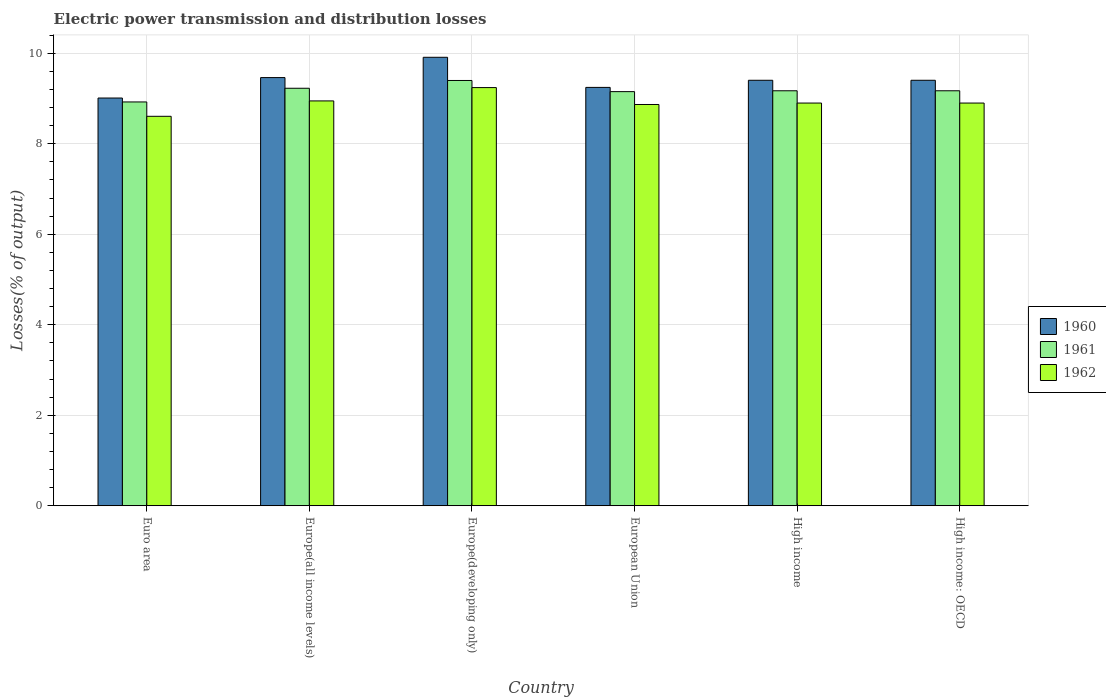How many groups of bars are there?
Your answer should be very brief. 6. Are the number of bars on each tick of the X-axis equal?
Your response must be concise. Yes. How many bars are there on the 2nd tick from the right?
Give a very brief answer. 3. What is the label of the 5th group of bars from the left?
Give a very brief answer. High income. In how many cases, is the number of bars for a given country not equal to the number of legend labels?
Provide a short and direct response. 0. What is the electric power transmission and distribution losses in 1960 in Europe(developing only)?
Your answer should be compact. 9.91. Across all countries, what is the maximum electric power transmission and distribution losses in 1962?
Offer a very short reply. 9.24. Across all countries, what is the minimum electric power transmission and distribution losses in 1961?
Your response must be concise. 8.92. In which country was the electric power transmission and distribution losses in 1962 maximum?
Your answer should be compact. Europe(developing only). What is the total electric power transmission and distribution losses in 1962 in the graph?
Your answer should be very brief. 53.46. What is the difference between the electric power transmission and distribution losses in 1962 in Europe(developing only) and that in European Union?
Ensure brevity in your answer.  0.37. What is the difference between the electric power transmission and distribution losses in 1962 in High income: OECD and the electric power transmission and distribution losses in 1960 in European Union?
Offer a very short reply. -0.35. What is the average electric power transmission and distribution losses in 1962 per country?
Your answer should be very brief. 8.91. What is the difference between the electric power transmission and distribution losses of/in 1960 and electric power transmission and distribution losses of/in 1961 in High income?
Make the answer very short. 0.23. In how many countries, is the electric power transmission and distribution losses in 1961 greater than 6 %?
Provide a succinct answer. 6. What is the ratio of the electric power transmission and distribution losses in 1960 in Europe(all income levels) to that in High income?
Offer a terse response. 1.01. Is the electric power transmission and distribution losses in 1962 in Euro area less than that in Europe(all income levels)?
Your answer should be very brief. Yes. What is the difference between the highest and the second highest electric power transmission and distribution losses in 1961?
Make the answer very short. 0.17. What is the difference between the highest and the lowest electric power transmission and distribution losses in 1960?
Offer a terse response. 0.9. Is the sum of the electric power transmission and distribution losses in 1962 in Europe(developing only) and High income: OECD greater than the maximum electric power transmission and distribution losses in 1960 across all countries?
Offer a very short reply. Yes. What does the 1st bar from the left in Europe(developing only) represents?
Your answer should be compact. 1960. Is it the case that in every country, the sum of the electric power transmission and distribution losses in 1960 and electric power transmission and distribution losses in 1961 is greater than the electric power transmission and distribution losses in 1962?
Keep it short and to the point. Yes. How many bars are there?
Keep it short and to the point. 18. Are all the bars in the graph horizontal?
Offer a very short reply. No. How many countries are there in the graph?
Your answer should be very brief. 6. What is the difference between two consecutive major ticks on the Y-axis?
Give a very brief answer. 2. Does the graph contain any zero values?
Offer a very short reply. No. Does the graph contain grids?
Give a very brief answer. Yes. How many legend labels are there?
Ensure brevity in your answer.  3. How are the legend labels stacked?
Provide a succinct answer. Vertical. What is the title of the graph?
Your answer should be compact. Electric power transmission and distribution losses. Does "1976" appear as one of the legend labels in the graph?
Offer a terse response. No. What is the label or title of the Y-axis?
Provide a short and direct response. Losses(% of output). What is the Losses(% of output) in 1960 in Euro area?
Offer a very short reply. 9.01. What is the Losses(% of output) of 1961 in Euro area?
Keep it short and to the point. 8.92. What is the Losses(% of output) in 1962 in Euro area?
Keep it short and to the point. 8.61. What is the Losses(% of output) of 1960 in Europe(all income levels)?
Ensure brevity in your answer.  9.46. What is the Losses(% of output) in 1961 in Europe(all income levels)?
Provide a short and direct response. 9.23. What is the Losses(% of output) of 1962 in Europe(all income levels)?
Give a very brief answer. 8.95. What is the Losses(% of output) in 1960 in Europe(developing only)?
Ensure brevity in your answer.  9.91. What is the Losses(% of output) of 1961 in Europe(developing only)?
Offer a terse response. 9.4. What is the Losses(% of output) of 1962 in Europe(developing only)?
Provide a succinct answer. 9.24. What is the Losses(% of output) of 1960 in European Union?
Your answer should be compact. 9.25. What is the Losses(% of output) of 1961 in European Union?
Give a very brief answer. 9.15. What is the Losses(% of output) of 1962 in European Union?
Keep it short and to the point. 8.87. What is the Losses(% of output) of 1960 in High income?
Your response must be concise. 9.4. What is the Losses(% of output) in 1961 in High income?
Offer a terse response. 9.17. What is the Losses(% of output) of 1962 in High income?
Provide a succinct answer. 8.9. What is the Losses(% of output) in 1960 in High income: OECD?
Ensure brevity in your answer.  9.4. What is the Losses(% of output) in 1961 in High income: OECD?
Provide a short and direct response. 9.17. What is the Losses(% of output) of 1962 in High income: OECD?
Your answer should be compact. 8.9. Across all countries, what is the maximum Losses(% of output) of 1960?
Make the answer very short. 9.91. Across all countries, what is the maximum Losses(% of output) in 1961?
Offer a very short reply. 9.4. Across all countries, what is the maximum Losses(% of output) of 1962?
Your response must be concise. 9.24. Across all countries, what is the minimum Losses(% of output) of 1960?
Provide a succinct answer. 9.01. Across all countries, what is the minimum Losses(% of output) of 1961?
Ensure brevity in your answer.  8.92. Across all countries, what is the minimum Losses(% of output) of 1962?
Give a very brief answer. 8.61. What is the total Losses(% of output) in 1960 in the graph?
Your response must be concise. 56.44. What is the total Losses(% of output) of 1961 in the graph?
Keep it short and to the point. 55.04. What is the total Losses(% of output) of 1962 in the graph?
Your response must be concise. 53.46. What is the difference between the Losses(% of output) in 1960 in Euro area and that in Europe(all income levels)?
Offer a very short reply. -0.45. What is the difference between the Losses(% of output) of 1961 in Euro area and that in Europe(all income levels)?
Make the answer very short. -0.3. What is the difference between the Losses(% of output) in 1962 in Euro area and that in Europe(all income levels)?
Provide a short and direct response. -0.34. What is the difference between the Losses(% of output) in 1961 in Euro area and that in Europe(developing only)?
Provide a short and direct response. -0.47. What is the difference between the Losses(% of output) of 1962 in Euro area and that in Europe(developing only)?
Your response must be concise. -0.63. What is the difference between the Losses(% of output) in 1960 in Euro area and that in European Union?
Provide a short and direct response. -0.23. What is the difference between the Losses(% of output) in 1961 in Euro area and that in European Union?
Your answer should be very brief. -0.23. What is the difference between the Losses(% of output) of 1962 in Euro area and that in European Union?
Your answer should be very brief. -0.26. What is the difference between the Losses(% of output) in 1960 in Euro area and that in High income?
Offer a terse response. -0.39. What is the difference between the Losses(% of output) of 1961 in Euro area and that in High income?
Your answer should be very brief. -0.25. What is the difference between the Losses(% of output) of 1962 in Euro area and that in High income?
Give a very brief answer. -0.29. What is the difference between the Losses(% of output) in 1960 in Euro area and that in High income: OECD?
Your answer should be compact. -0.39. What is the difference between the Losses(% of output) of 1961 in Euro area and that in High income: OECD?
Make the answer very short. -0.25. What is the difference between the Losses(% of output) in 1962 in Euro area and that in High income: OECD?
Make the answer very short. -0.29. What is the difference between the Losses(% of output) in 1960 in Europe(all income levels) and that in Europe(developing only)?
Provide a short and direct response. -0.45. What is the difference between the Losses(% of output) of 1961 in Europe(all income levels) and that in Europe(developing only)?
Your response must be concise. -0.17. What is the difference between the Losses(% of output) in 1962 in Europe(all income levels) and that in Europe(developing only)?
Your answer should be compact. -0.29. What is the difference between the Losses(% of output) in 1960 in Europe(all income levels) and that in European Union?
Your answer should be compact. 0.22. What is the difference between the Losses(% of output) in 1961 in Europe(all income levels) and that in European Union?
Provide a succinct answer. 0.07. What is the difference between the Losses(% of output) of 1962 in Europe(all income levels) and that in European Union?
Your answer should be very brief. 0.08. What is the difference between the Losses(% of output) in 1960 in Europe(all income levels) and that in High income?
Provide a short and direct response. 0.06. What is the difference between the Losses(% of output) in 1961 in Europe(all income levels) and that in High income?
Your answer should be compact. 0.06. What is the difference between the Losses(% of output) in 1962 in Europe(all income levels) and that in High income?
Make the answer very short. 0.05. What is the difference between the Losses(% of output) in 1960 in Europe(all income levels) and that in High income: OECD?
Your answer should be very brief. 0.06. What is the difference between the Losses(% of output) in 1961 in Europe(all income levels) and that in High income: OECD?
Keep it short and to the point. 0.06. What is the difference between the Losses(% of output) in 1962 in Europe(all income levels) and that in High income: OECD?
Ensure brevity in your answer.  0.05. What is the difference between the Losses(% of output) of 1960 in Europe(developing only) and that in European Union?
Offer a terse response. 0.67. What is the difference between the Losses(% of output) of 1961 in Europe(developing only) and that in European Union?
Provide a succinct answer. 0.25. What is the difference between the Losses(% of output) in 1962 in Europe(developing only) and that in European Union?
Give a very brief answer. 0.37. What is the difference between the Losses(% of output) in 1960 in Europe(developing only) and that in High income?
Make the answer very short. 0.51. What is the difference between the Losses(% of output) in 1961 in Europe(developing only) and that in High income?
Provide a short and direct response. 0.23. What is the difference between the Losses(% of output) in 1962 in Europe(developing only) and that in High income?
Offer a very short reply. 0.34. What is the difference between the Losses(% of output) in 1960 in Europe(developing only) and that in High income: OECD?
Provide a short and direct response. 0.51. What is the difference between the Losses(% of output) in 1961 in Europe(developing only) and that in High income: OECD?
Offer a very short reply. 0.23. What is the difference between the Losses(% of output) of 1962 in Europe(developing only) and that in High income: OECD?
Give a very brief answer. 0.34. What is the difference between the Losses(% of output) in 1960 in European Union and that in High income?
Offer a very short reply. -0.16. What is the difference between the Losses(% of output) in 1961 in European Union and that in High income?
Your answer should be very brief. -0.02. What is the difference between the Losses(% of output) in 1962 in European Union and that in High income?
Provide a succinct answer. -0.03. What is the difference between the Losses(% of output) in 1960 in European Union and that in High income: OECD?
Give a very brief answer. -0.16. What is the difference between the Losses(% of output) of 1961 in European Union and that in High income: OECD?
Offer a terse response. -0.02. What is the difference between the Losses(% of output) in 1962 in European Union and that in High income: OECD?
Provide a succinct answer. -0.03. What is the difference between the Losses(% of output) of 1960 in High income and that in High income: OECD?
Your answer should be very brief. 0. What is the difference between the Losses(% of output) in 1961 in High income and that in High income: OECD?
Provide a short and direct response. 0. What is the difference between the Losses(% of output) in 1962 in High income and that in High income: OECD?
Provide a short and direct response. 0. What is the difference between the Losses(% of output) in 1960 in Euro area and the Losses(% of output) in 1961 in Europe(all income levels)?
Keep it short and to the point. -0.22. What is the difference between the Losses(% of output) of 1960 in Euro area and the Losses(% of output) of 1962 in Europe(all income levels)?
Keep it short and to the point. 0.06. What is the difference between the Losses(% of output) of 1961 in Euro area and the Losses(% of output) of 1962 in Europe(all income levels)?
Your response must be concise. -0.02. What is the difference between the Losses(% of output) of 1960 in Euro area and the Losses(% of output) of 1961 in Europe(developing only)?
Make the answer very short. -0.39. What is the difference between the Losses(% of output) of 1960 in Euro area and the Losses(% of output) of 1962 in Europe(developing only)?
Your answer should be very brief. -0.23. What is the difference between the Losses(% of output) in 1961 in Euro area and the Losses(% of output) in 1962 in Europe(developing only)?
Ensure brevity in your answer.  -0.32. What is the difference between the Losses(% of output) in 1960 in Euro area and the Losses(% of output) in 1961 in European Union?
Your answer should be very brief. -0.14. What is the difference between the Losses(% of output) in 1960 in Euro area and the Losses(% of output) in 1962 in European Union?
Give a very brief answer. 0.14. What is the difference between the Losses(% of output) of 1961 in Euro area and the Losses(% of output) of 1962 in European Union?
Offer a terse response. 0.06. What is the difference between the Losses(% of output) in 1960 in Euro area and the Losses(% of output) in 1961 in High income?
Provide a short and direct response. -0.16. What is the difference between the Losses(% of output) in 1960 in Euro area and the Losses(% of output) in 1962 in High income?
Offer a terse response. 0.11. What is the difference between the Losses(% of output) in 1961 in Euro area and the Losses(% of output) in 1962 in High income?
Offer a terse response. 0.02. What is the difference between the Losses(% of output) in 1960 in Euro area and the Losses(% of output) in 1961 in High income: OECD?
Your answer should be very brief. -0.16. What is the difference between the Losses(% of output) of 1960 in Euro area and the Losses(% of output) of 1962 in High income: OECD?
Keep it short and to the point. 0.11. What is the difference between the Losses(% of output) in 1961 in Euro area and the Losses(% of output) in 1962 in High income: OECD?
Your response must be concise. 0.02. What is the difference between the Losses(% of output) of 1960 in Europe(all income levels) and the Losses(% of output) of 1961 in Europe(developing only)?
Keep it short and to the point. 0.06. What is the difference between the Losses(% of output) of 1960 in Europe(all income levels) and the Losses(% of output) of 1962 in Europe(developing only)?
Your answer should be compact. 0.22. What is the difference between the Losses(% of output) of 1961 in Europe(all income levels) and the Losses(% of output) of 1962 in Europe(developing only)?
Give a very brief answer. -0.01. What is the difference between the Losses(% of output) of 1960 in Europe(all income levels) and the Losses(% of output) of 1961 in European Union?
Give a very brief answer. 0.31. What is the difference between the Losses(% of output) of 1960 in Europe(all income levels) and the Losses(% of output) of 1962 in European Union?
Your response must be concise. 0.59. What is the difference between the Losses(% of output) of 1961 in Europe(all income levels) and the Losses(% of output) of 1962 in European Union?
Ensure brevity in your answer.  0.36. What is the difference between the Losses(% of output) in 1960 in Europe(all income levels) and the Losses(% of output) in 1961 in High income?
Offer a very short reply. 0.29. What is the difference between the Losses(% of output) in 1960 in Europe(all income levels) and the Losses(% of output) in 1962 in High income?
Give a very brief answer. 0.56. What is the difference between the Losses(% of output) of 1961 in Europe(all income levels) and the Losses(% of output) of 1962 in High income?
Make the answer very short. 0.33. What is the difference between the Losses(% of output) in 1960 in Europe(all income levels) and the Losses(% of output) in 1961 in High income: OECD?
Your answer should be very brief. 0.29. What is the difference between the Losses(% of output) in 1960 in Europe(all income levels) and the Losses(% of output) in 1962 in High income: OECD?
Give a very brief answer. 0.56. What is the difference between the Losses(% of output) in 1961 in Europe(all income levels) and the Losses(% of output) in 1962 in High income: OECD?
Provide a short and direct response. 0.33. What is the difference between the Losses(% of output) of 1960 in Europe(developing only) and the Losses(% of output) of 1961 in European Union?
Provide a succinct answer. 0.76. What is the difference between the Losses(% of output) of 1960 in Europe(developing only) and the Losses(% of output) of 1962 in European Union?
Make the answer very short. 1.04. What is the difference between the Losses(% of output) in 1961 in Europe(developing only) and the Losses(% of output) in 1962 in European Union?
Offer a very short reply. 0.53. What is the difference between the Losses(% of output) of 1960 in Europe(developing only) and the Losses(% of output) of 1961 in High income?
Give a very brief answer. 0.74. What is the difference between the Losses(% of output) of 1960 in Europe(developing only) and the Losses(% of output) of 1962 in High income?
Your answer should be compact. 1.01. What is the difference between the Losses(% of output) in 1961 in Europe(developing only) and the Losses(% of output) in 1962 in High income?
Make the answer very short. 0.5. What is the difference between the Losses(% of output) of 1960 in Europe(developing only) and the Losses(% of output) of 1961 in High income: OECD?
Offer a very short reply. 0.74. What is the difference between the Losses(% of output) of 1960 in Europe(developing only) and the Losses(% of output) of 1962 in High income: OECD?
Provide a succinct answer. 1.01. What is the difference between the Losses(% of output) in 1961 in Europe(developing only) and the Losses(% of output) in 1962 in High income: OECD?
Ensure brevity in your answer.  0.5. What is the difference between the Losses(% of output) of 1960 in European Union and the Losses(% of output) of 1961 in High income?
Provide a succinct answer. 0.07. What is the difference between the Losses(% of output) in 1960 in European Union and the Losses(% of output) in 1962 in High income?
Keep it short and to the point. 0.35. What is the difference between the Losses(% of output) in 1961 in European Union and the Losses(% of output) in 1962 in High income?
Your response must be concise. 0.25. What is the difference between the Losses(% of output) of 1960 in European Union and the Losses(% of output) of 1961 in High income: OECD?
Your response must be concise. 0.07. What is the difference between the Losses(% of output) in 1960 in European Union and the Losses(% of output) in 1962 in High income: OECD?
Your response must be concise. 0.35. What is the difference between the Losses(% of output) of 1961 in European Union and the Losses(% of output) of 1962 in High income: OECD?
Your answer should be compact. 0.25. What is the difference between the Losses(% of output) in 1960 in High income and the Losses(% of output) in 1961 in High income: OECD?
Your answer should be compact. 0.23. What is the difference between the Losses(% of output) in 1960 in High income and the Losses(% of output) in 1962 in High income: OECD?
Your answer should be compact. 0.5. What is the difference between the Losses(% of output) in 1961 in High income and the Losses(% of output) in 1962 in High income: OECD?
Your response must be concise. 0.27. What is the average Losses(% of output) in 1960 per country?
Offer a terse response. 9.41. What is the average Losses(% of output) of 1961 per country?
Your answer should be very brief. 9.17. What is the average Losses(% of output) of 1962 per country?
Your response must be concise. 8.91. What is the difference between the Losses(% of output) of 1960 and Losses(% of output) of 1961 in Euro area?
Provide a succinct answer. 0.09. What is the difference between the Losses(% of output) in 1960 and Losses(% of output) in 1962 in Euro area?
Keep it short and to the point. 0.4. What is the difference between the Losses(% of output) of 1961 and Losses(% of output) of 1962 in Euro area?
Provide a succinct answer. 0.32. What is the difference between the Losses(% of output) of 1960 and Losses(% of output) of 1961 in Europe(all income levels)?
Your answer should be very brief. 0.24. What is the difference between the Losses(% of output) in 1960 and Losses(% of output) in 1962 in Europe(all income levels)?
Offer a terse response. 0.52. What is the difference between the Losses(% of output) in 1961 and Losses(% of output) in 1962 in Europe(all income levels)?
Keep it short and to the point. 0.28. What is the difference between the Losses(% of output) in 1960 and Losses(% of output) in 1961 in Europe(developing only)?
Your answer should be very brief. 0.51. What is the difference between the Losses(% of output) of 1960 and Losses(% of output) of 1962 in Europe(developing only)?
Ensure brevity in your answer.  0.67. What is the difference between the Losses(% of output) in 1961 and Losses(% of output) in 1962 in Europe(developing only)?
Your response must be concise. 0.16. What is the difference between the Losses(% of output) of 1960 and Losses(% of output) of 1961 in European Union?
Ensure brevity in your answer.  0.09. What is the difference between the Losses(% of output) of 1960 and Losses(% of output) of 1962 in European Union?
Provide a succinct answer. 0.38. What is the difference between the Losses(% of output) of 1961 and Losses(% of output) of 1962 in European Union?
Ensure brevity in your answer.  0.28. What is the difference between the Losses(% of output) in 1960 and Losses(% of output) in 1961 in High income?
Keep it short and to the point. 0.23. What is the difference between the Losses(% of output) in 1960 and Losses(% of output) in 1962 in High income?
Keep it short and to the point. 0.5. What is the difference between the Losses(% of output) in 1961 and Losses(% of output) in 1962 in High income?
Your response must be concise. 0.27. What is the difference between the Losses(% of output) of 1960 and Losses(% of output) of 1961 in High income: OECD?
Offer a terse response. 0.23. What is the difference between the Losses(% of output) in 1960 and Losses(% of output) in 1962 in High income: OECD?
Your response must be concise. 0.5. What is the difference between the Losses(% of output) of 1961 and Losses(% of output) of 1962 in High income: OECD?
Offer a terse response. 0.27. What is the ratio of the Losses(% of output) in 1960 in Euro area to that in Europe(all income levels)?
Give a very brief answer. 0.95. What is the ratio of the Losses(% of output) of 1961 in Euro area to that in Europe(all income levels)?
Ensure brevity in your answer.  0.97. What is the ratio of the Losses(% of output) in 1962 in Euro area to that in Europe(all income levels)?
Give a very brief answer. 0.96. What is the ratio of the Losses(% of output) of 1960 in Euro area to that in Europe(developing only)?
Keep it short and to the point. 0.91. What is the ratio of the Losses(% of output) in 1961 in Euro area to that in Europe(developing only)?
Offer a very short reply. 0.95. What is the ratio of the Losses(% of output) in 1962 in Euro area to that in Europe(developing only)?
Your answer should be very brief. 0.93. What is the ratio of the Losses(% of output) in 1960 in Euro area to that in European Union?
Make the answer very short. 0.97. What is the ratio of the Losses(% of output) in 1961 in Euro area to that in European Union?
Your response must be concise. 0.98. What is the ratio of the Losses(% of output) in 1962 in Euro area to that in European Union?
Offer a very short reply. 0.97. What is the ratio of the Losses(% of output) of 1961 in Euro area to that in High income?
Ensure brevity in your answer.  0.97. What is the ratio of the Losses(% of output) in 1962 in Euro area to that in High income?
Your answer should be very brief. 0.97. What is the ratio of the Losses(% of output) of 1961 in Euro area to that in High income: OECD?
Provide a short and direct response. 0.97. What is the ratio of the Losses(% of output) of 1962 in Euro area to that in High income: OECD?
Provide a succinct answer. 0.97. What is the ratio of the Losses(% of output) of 1960 in Europe(all income levels) to that in Europe(developing only)?
Make the answer very short. 0.95. What is the ratio of the Losses(% of output) of 1961 in Europe(all income levels) to that in Europe(developing only)?
Make the answer very short. 0.98. What is the ratio of the Losses(% of output) of 1962 in Europe(all income levels) to that in Europe(developing only)?
Offer a very short reply. 0.97. What is the ratio of the Losses(% of output) of 1960 in Europe(all income levels) to that in European Union?
Offer a terse response. 1.02. What is the ratio of the Losses(% of output) in 1961 in Europe(all income levels) to that in European Union?
Give a very brief answer. 1.01. What is the ratio of the Losses(% of output) of 1962 in Europe(all income levels) to that in European Union?
Provide a short and direct response. 1.01. What is the ratio of the Losses(% of output) in 1960 in Europe(all income levels) to that in High income?
Make the answer very short. 1.01. What is the ratio of the Losses(% of output) of 1961 in Europe(all income levels) to that in High income?
Your answer should be very brief. 1.01. What is the ratio of the Losses(% of output) of 1962 in Europe(all income levels) to that in High income?
Offer a very short reply. 1.01. What is the ratio of the Losses(% of output) of 1960 in Europe(all income levels) to that in High income: OECD?
Your answer should be compact. 1.01. What is the ratio of the Losses(% of output) of 1960 in Europe(developing only) to that in European Union?
Ensure brevity in your answer.  1.07. What is the ratio of the Losses(% of output) in 1961 in Europe(developing only) to that in European Union?
Ensure brevity in your answer.  1.03. What is the ratio of the Losses(% of output) of 1962 in Europe(developing only) to that in European Union?
Your answer should be compact. 1.04. What is the ratio of the Losses(% of output) of 1960 in Europe(developing only) to that in High income?
Provide a short and direct response. 1.05. What is the ratio of the Losses(% of output) in 1961 in Europe(developing only) to that in High income?
Make the answer very short. 1.02. What is the ratio of the Losses(% of output) in 1962 in Europe(developing only) to that in High income?
Offer a very short reply. 1.04. What is the ratio of the Losses(% of output) in 1960 in Europe(developing only) to that in High income: OECD?
Your answer should be compact. 1.05. What is the ratio of the Losses(% of output) of 1961 in Europe(developing only) to that in High income: OECD?
Keep it short and to the point. 1.02. What is the ratio of the Losses(% of output) in 1962 in Europe(developing only) to that in High income: OECD?
Offer a very short reply. 1.04. What is the ratio of the Losses(% of output) in 1960 in European Union to that in High income?
Give a very brief answer. 0.98. What is the ratio of the Losses(% of output) in 1962 in European Union to that in High income?
Ensure brevity in your answer.  1. What is the ratio of the Losses(% of output) of 1960 in European Union to that in High income: OECD?
Ensure brevity in your answer.  0.98. What is the ratio of the Losses(% of output) of 1961 in European Union to that in High income: OECD?
Your answer should be very brief. 1. What is the ratio of the Losses(% of output) of 1962 in European Union to that in High income: OECD?
Provide a succinct answer. 1. What is the ratio of the Losses(% of output) of 1961 in High income to that in High income: OECD?
Keep it short and to the point. 1. What is the ratio of the Losses(% of output) in 1962 in High income to that in High income: OECD?
Offer a terse response. 1. What is the difference between the highest and the second highest Losses(% of output) in 1960?
Make the answer very short. 0.45. What is the difference between the highest and the second highest Losses(% of output) of 1961?
Your answer should be compact. 0.17. What is the difference between the highest and the second highest Losses(% of output) of 1962?
Offer a very short reply. 0.29. What is the difference between the highest and the lowest Losses(% of output) in 1961?
Give a very brief answer. 0.47. What is the difference between the highest and the lowest Losses(% of output) of 1962?
Ensure brevity in your answer.  0.63. 